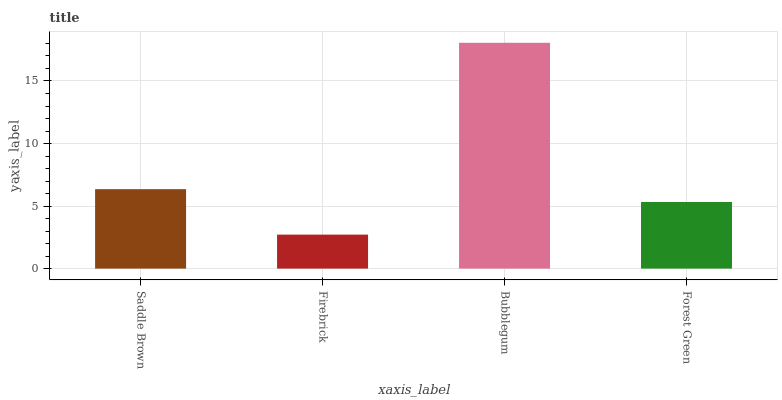Is Firebrick the minimum?
Answer yes or no. Yes. Is Bubblegum the maximum?
Answer yes or no. Yes. Is Bubblegum the minimum?
Answer yes or no. No. Is Firebrick the maximum?
Answer yes or no. No. Is Bubblegum greater than Firebrick?
Answer yes or no. Yes. Is Firebrick less than Bubblegum?
Answer yes or no. Yes. Is Firebrick greater than Bubblegum?
Answer yes or no. No. Is Bubblegum less than Firebrick?
Answer yes or no. No. Is Saddle Brown the high median?
Answer yes or no. Yes. Is Forest Green the low median?
Answer yes or no. Yes. Is Forest Green the high median?
Answer yes or no. No. Is Firebrick the low median?
Answer yes or no. No. 